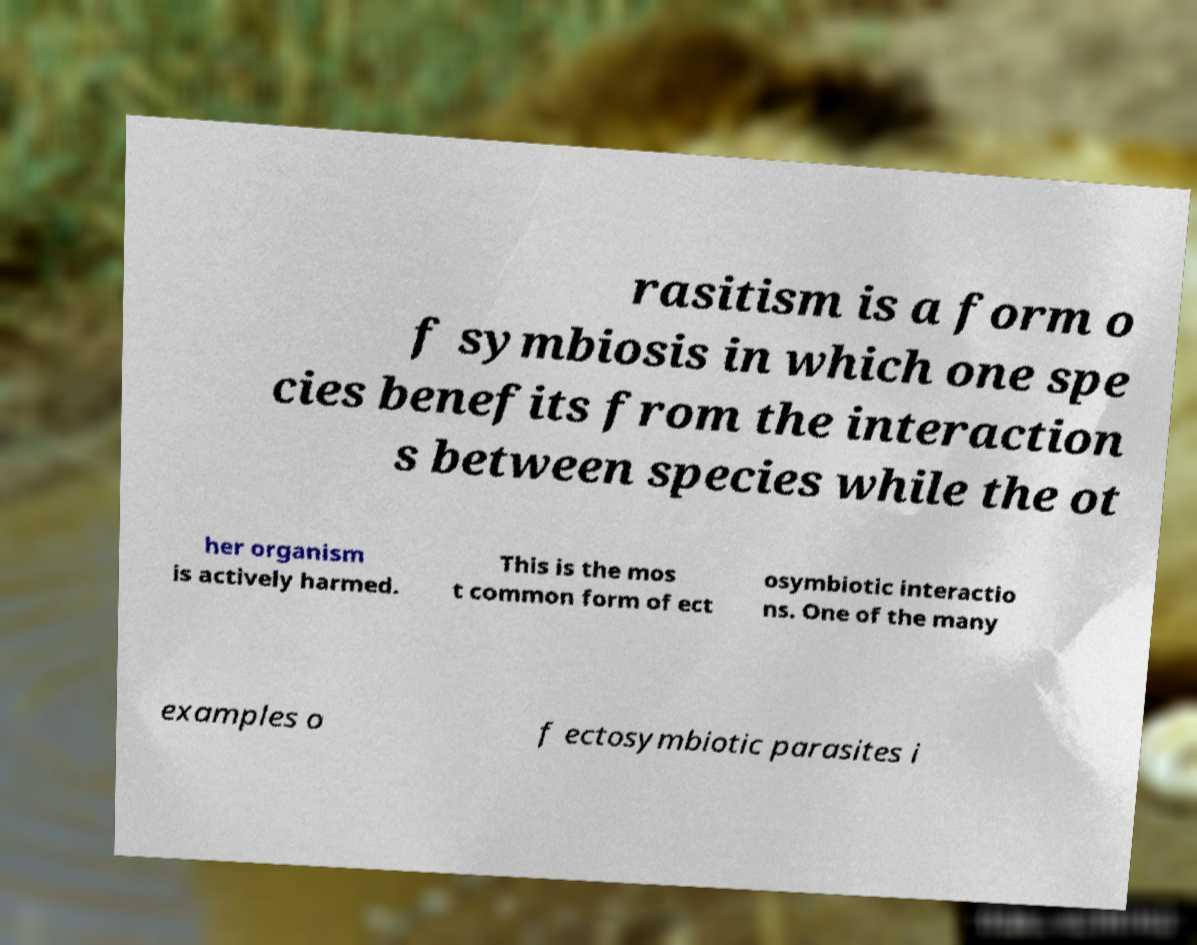Can you accurately transcribe the text from the provided image for me? rasitism is a form o f symbiosis in which one spe cies benefits from the interaction s between species while the ot her organism is actively harmed. This is the mos t common form of ect osymbiotic interactio ns. One of the many examples o f ectosymbiotic parasites i 